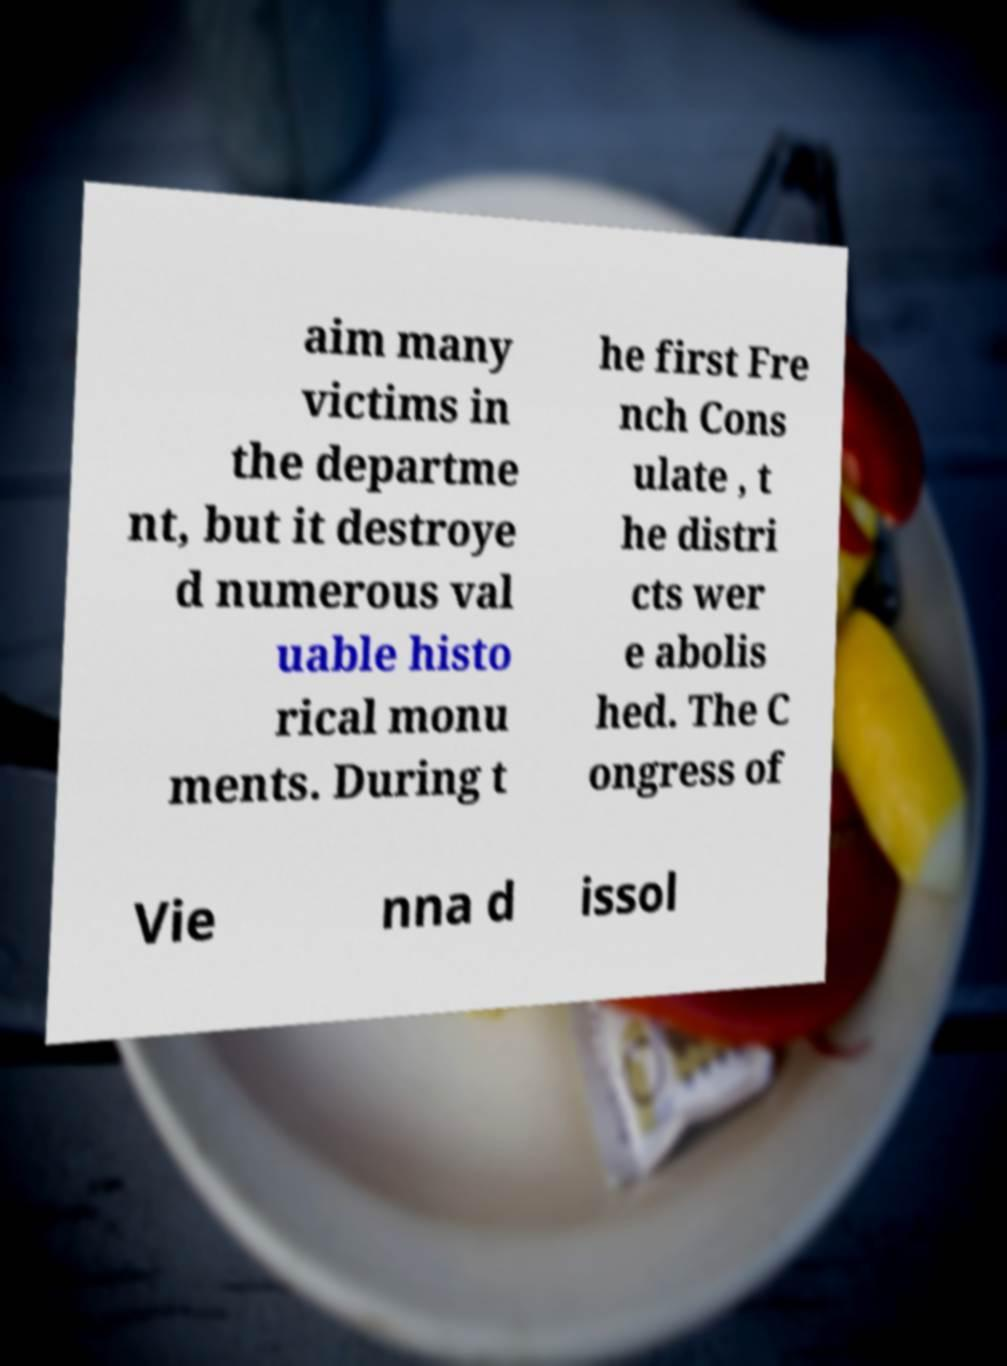Please read and relay the text visible in this image. What does it say? aim many victims in the departme nt, but it destroye d numerous val uable histo rical monu ments. During t he first Fre nch Cons ulate , t he distri cts wer e abolis hed. The C ongress of Vie nna d issol 